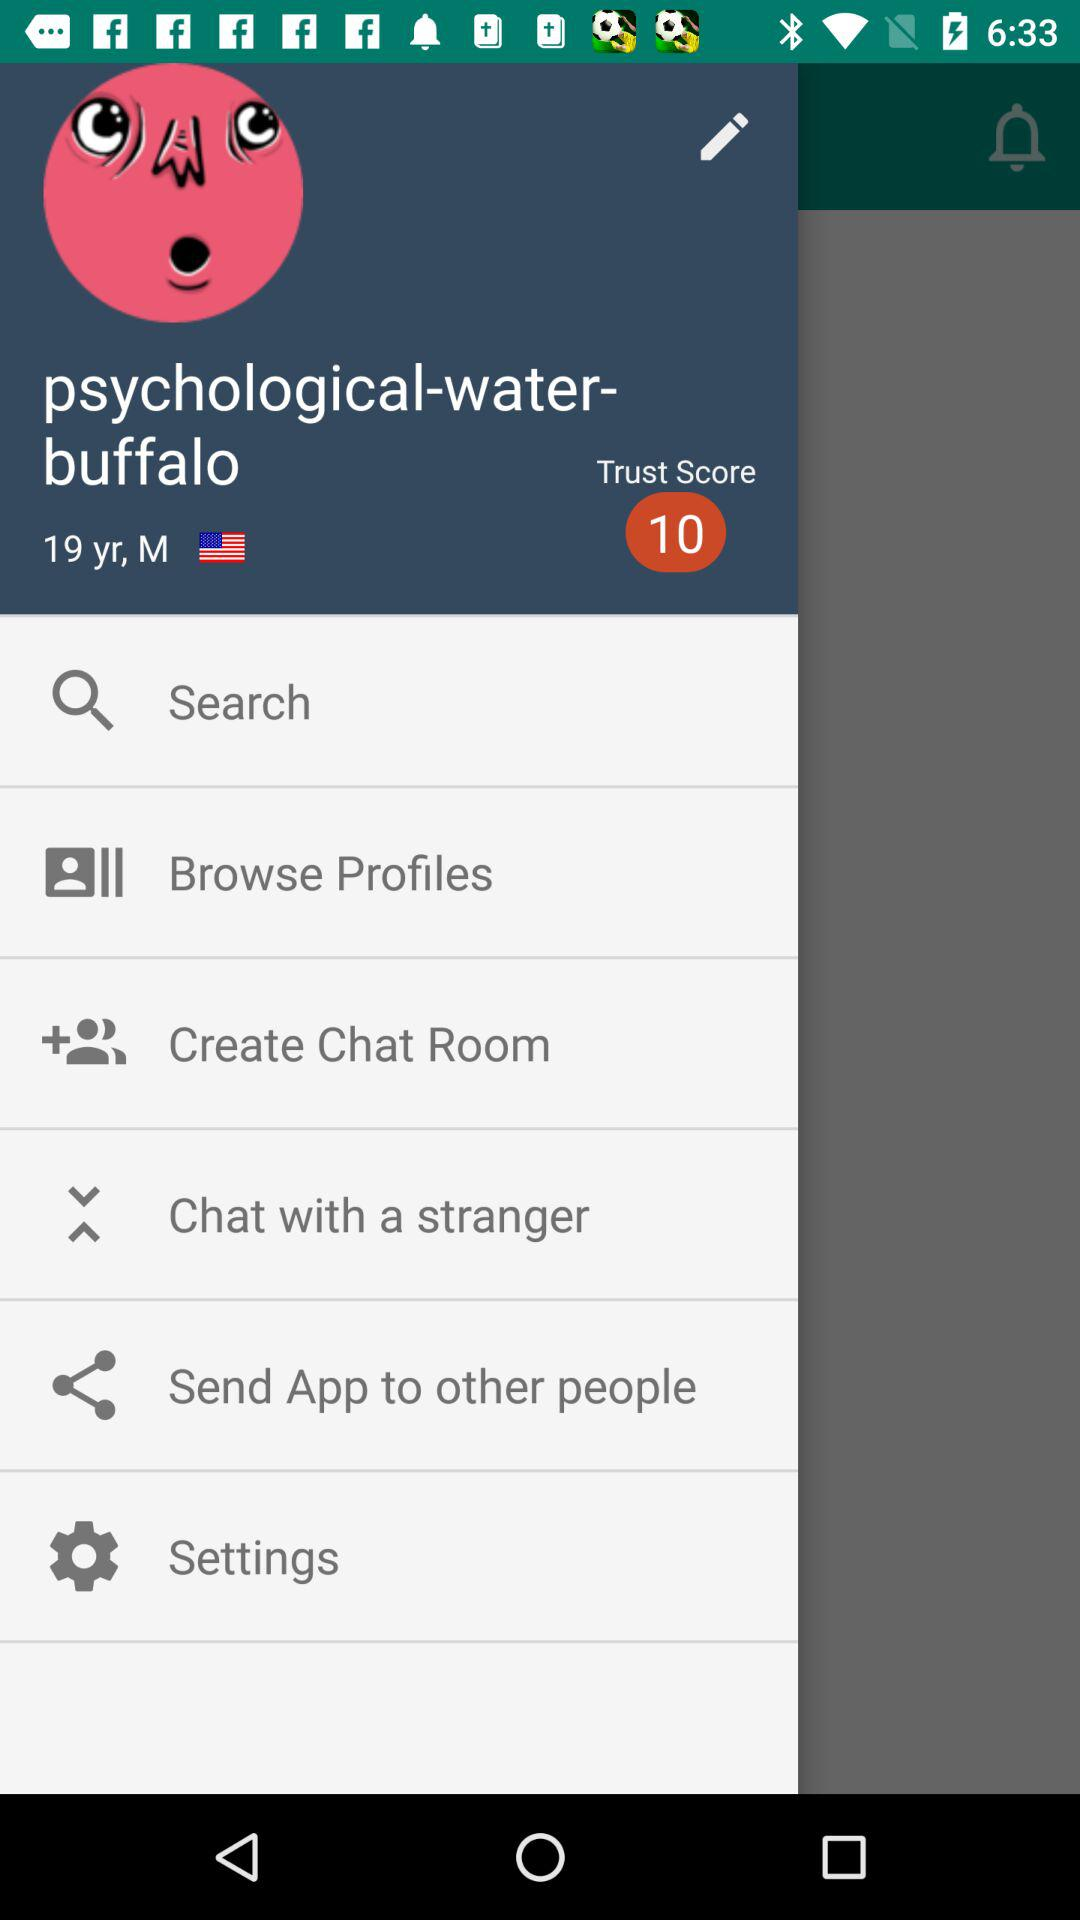What is the trust score? The trust score is 10. 